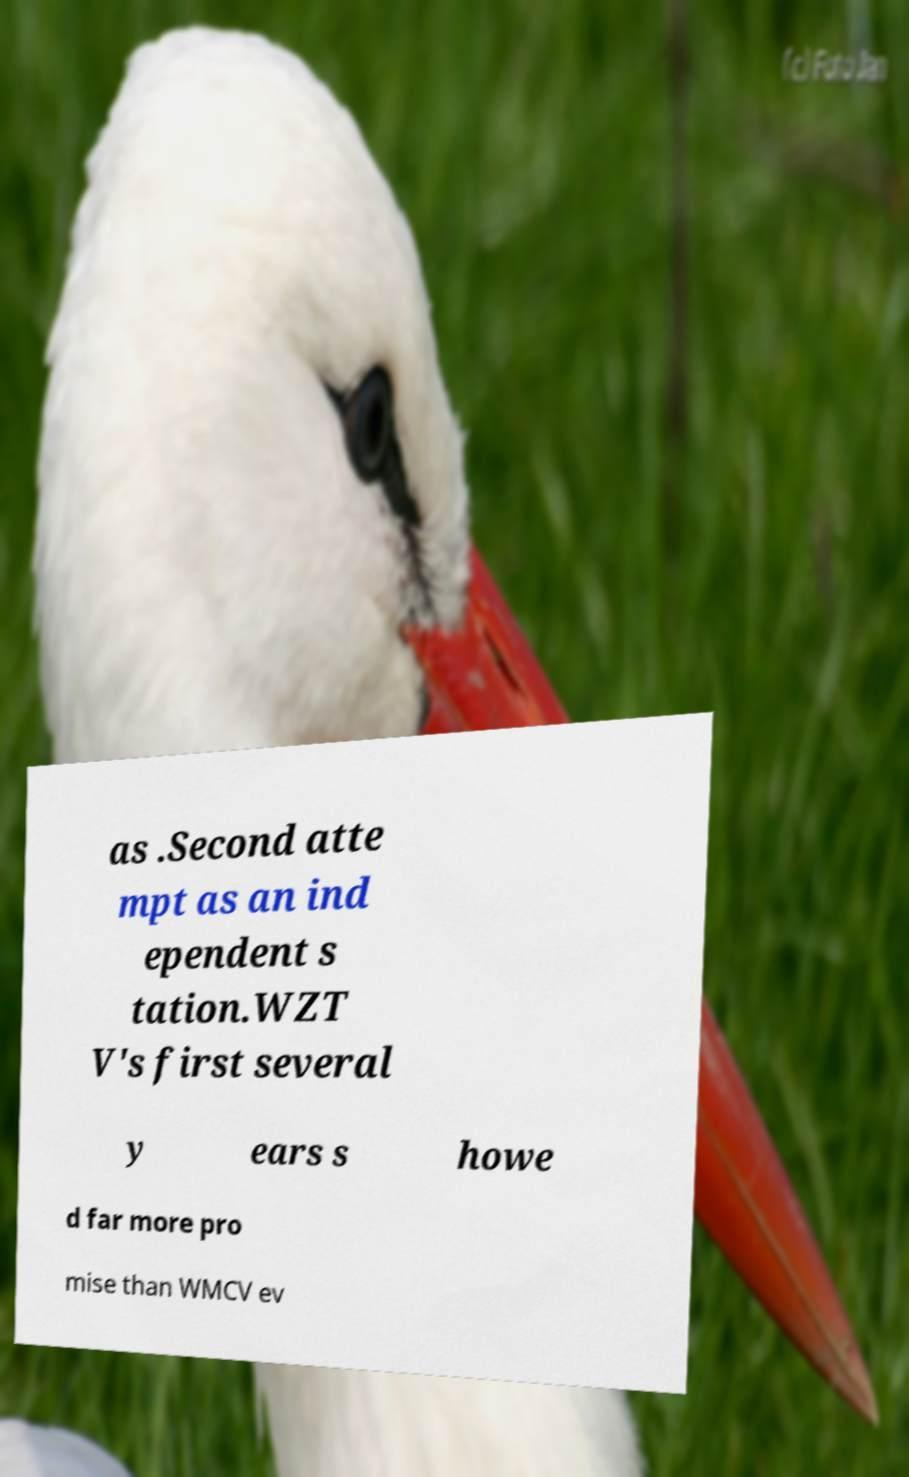Please identify and transcribe the text found in this image. as .Second atte mpt as an ind ependent s tation.WZT V's first several y ears s howe d far more pro mise than WMCV ev 